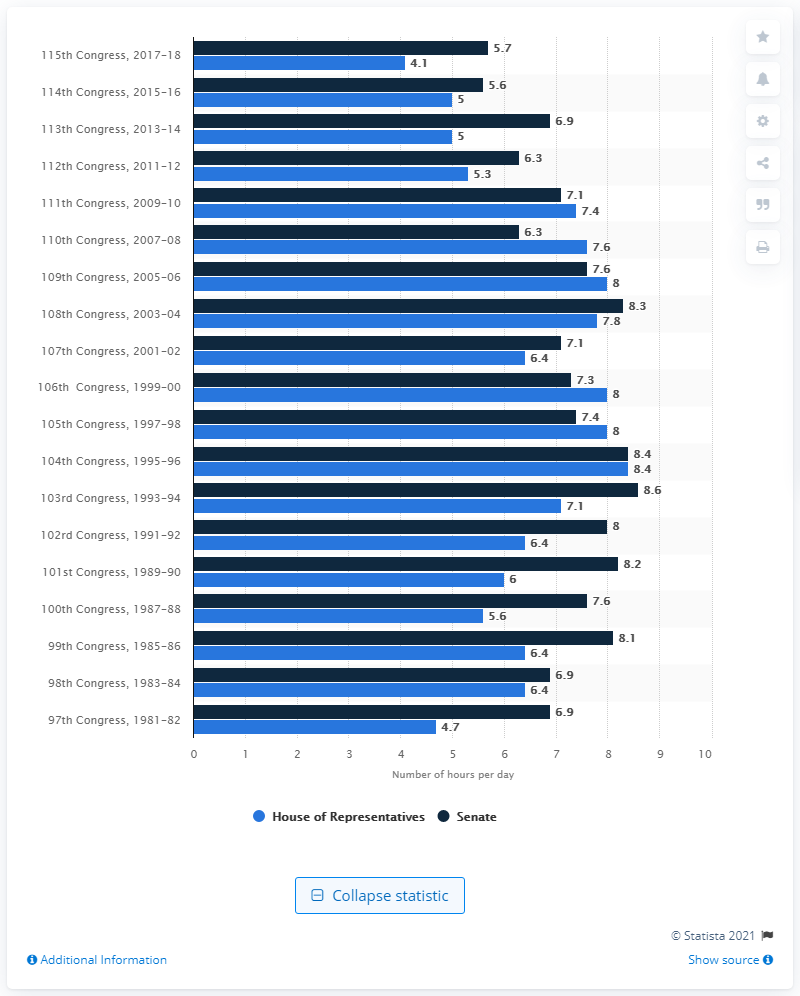Point out several critical features in this image. During the 115th Congress, the Senate was in session for an average of 5.7 hours per day. 